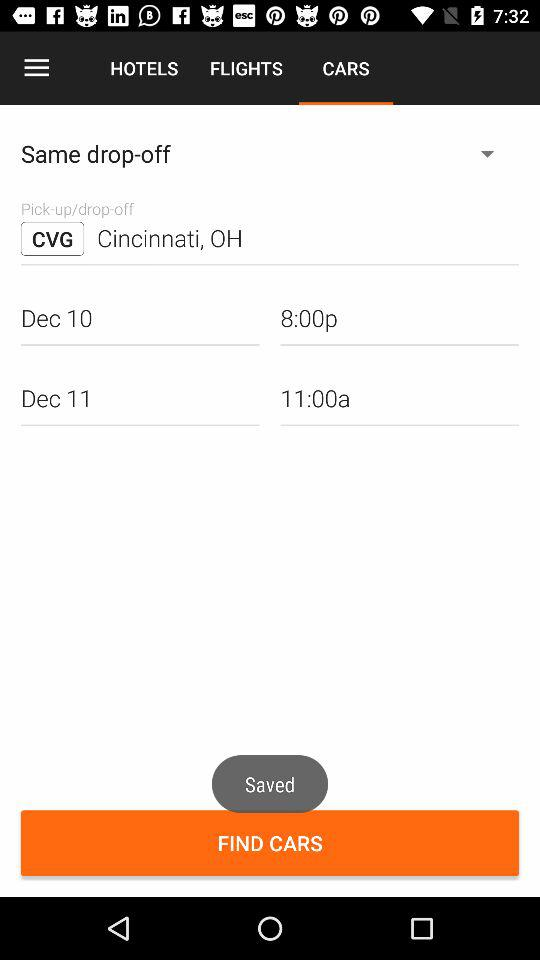How many days are between the two pick-up dates?
Answer the question using a single word or phrase. 1 